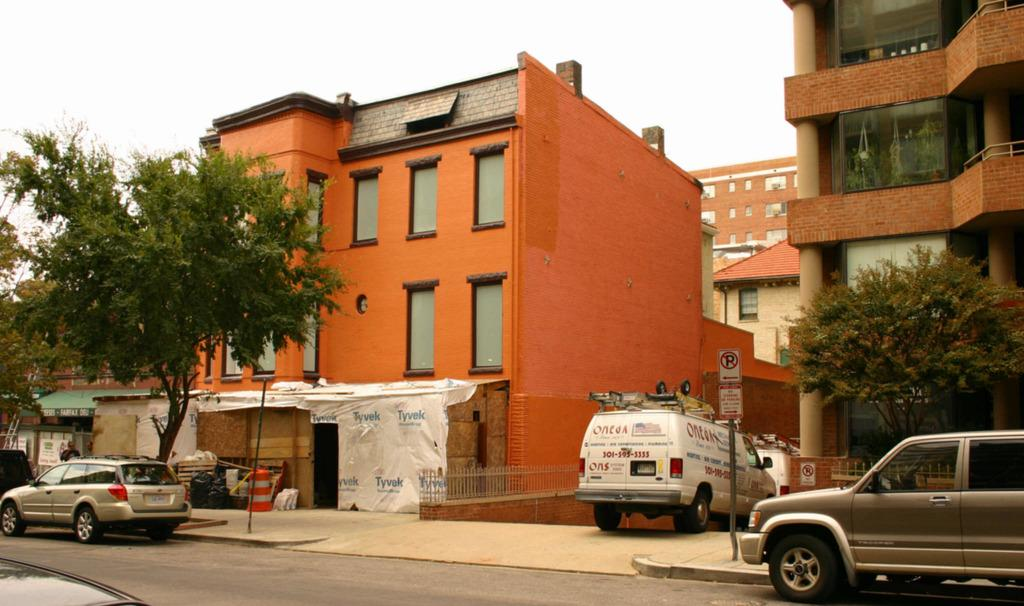What type of structures can be seen in the image? There are buildings in the image. What other natural elements are present in the image? There are trees in the image. What can be found on the sidewalk in the image? There are sign boards on the sidewalk. What type of vehicles are parked in the image? Cars are parked in the image. Where can the books be found in the image? There are no books present in the image. What type of yarn is being used to create the trees in the image? The trees in the image are natural, and there is no yarn involved in their creation. 